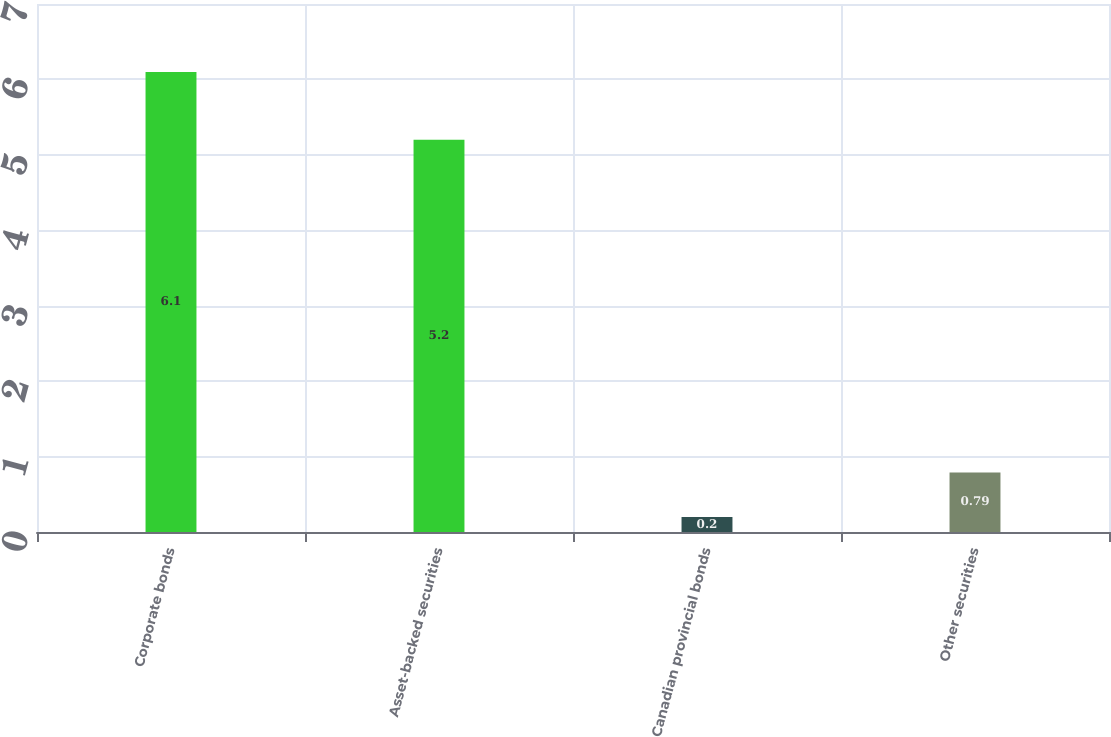<chart> <loc_0><loc_0><loc_500><loc_500><bar_chart><fcel>Corporate bonds<fcel>Asset-backed securities<fcel>Canadian provincial bonds<fcel>Other securities<nl><fcel>6.1<fcel>5.2<fcel>0.2<fcel>0.79<nl></chart> 